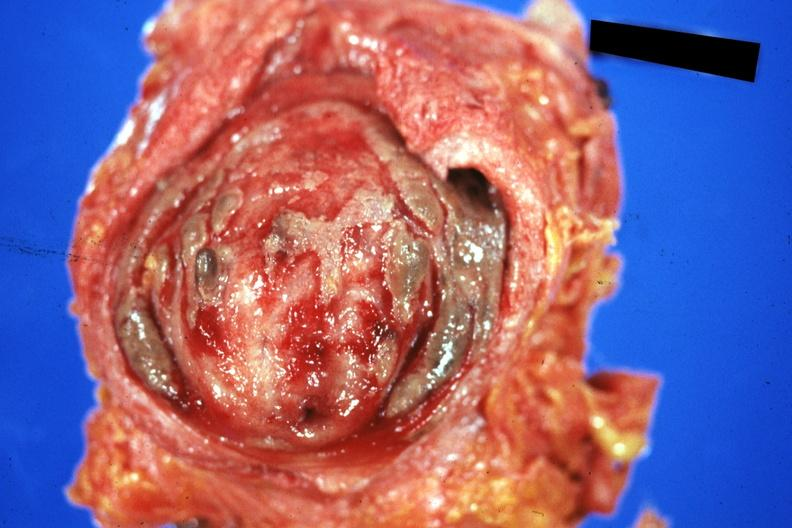s stomach present?
Answer the question using a single word or phrase. No 